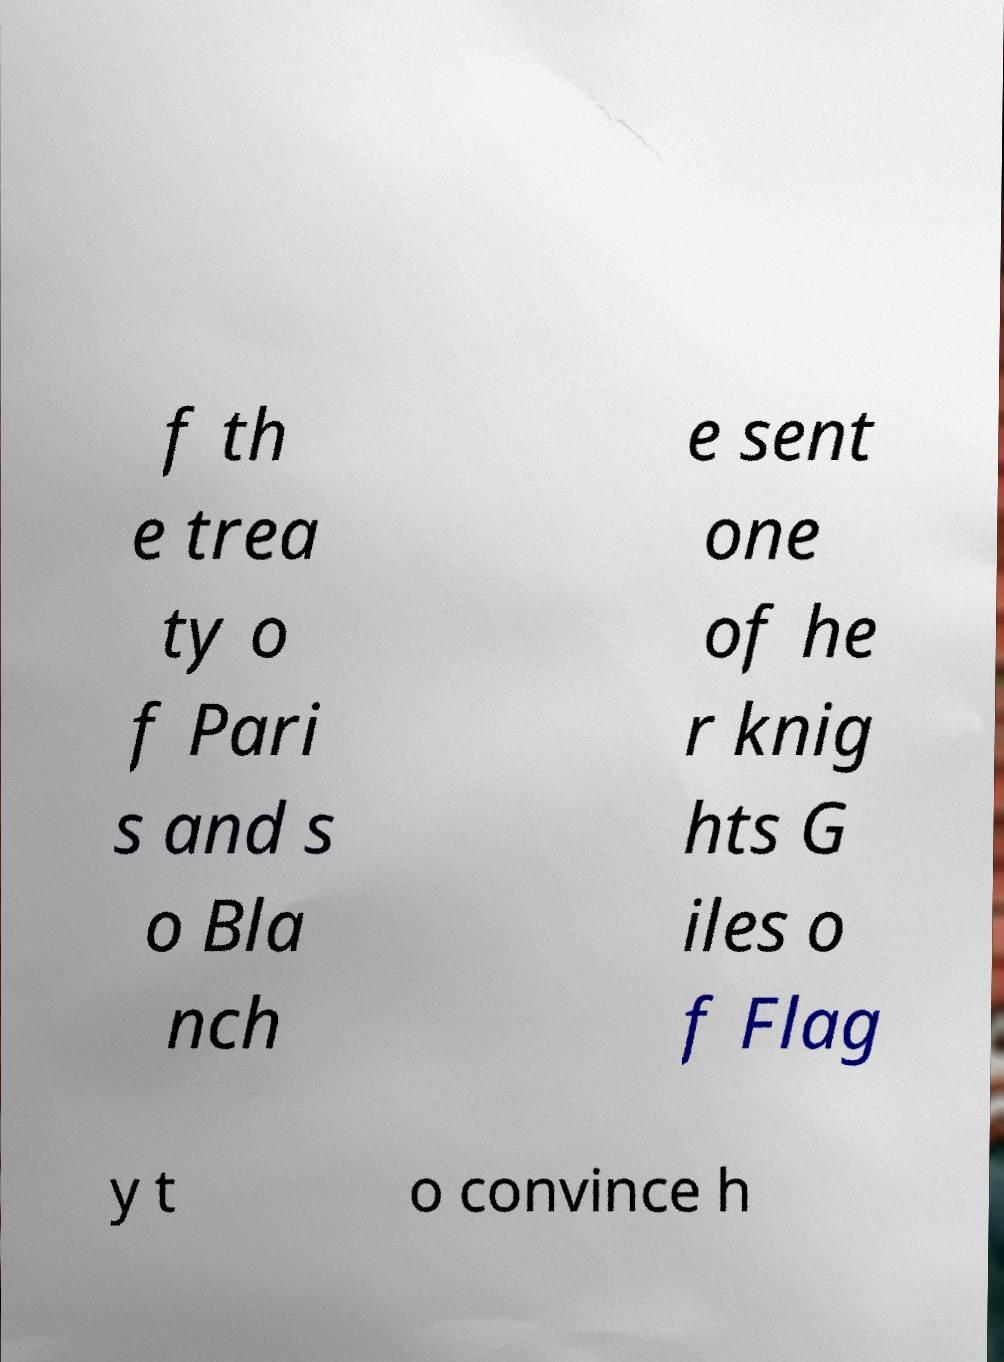What messages or text are displayed in this image? I need them in a readable, typed format. f th e trea ty o f Pari s and s o Bla nch e sent one of he r knig hts G iles o f Flag y t o convince h 